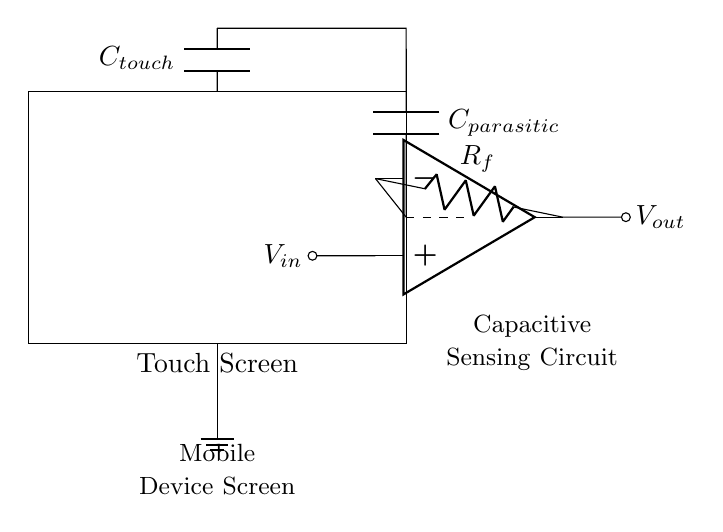What is the input voltage of the operational amplifier? The input voltage, represented as V_in in the circuit, is coming from a touch sensor, but the exact value is not labeled directly in the diagram. The analysis assumes a typical scenario where V_in may be a standard value like 3.3V or 5V.
Answer: V_in What type of capacitor is represented by C_touch? C_touch is a capacitive touch sensor which detects the change in capacitance caused by a user touching the screen. This type of capacitor is specifically designed for touch sensing applications.
Answer: Capacitive touch sensor What is the function of R_f in this circuit? R_f is a feedback resistor connected between the output and the inverting input of the operational amplifier. Its primary function is to set the gain of the amplifier circuit, influencing the sensitivity of the capacitive sensing.
Answer: Feedback resistor How does the parasitic capacitance affect the sensing capability? Parasitic capacitance, represented in the circuit as C_parasitic, can negatively influence the accuracy and reliability of touch detection by creating noise or false signals in conjunction with the intended capacitive touch.
Answer: Negatively influences detection What would happen if C_touch is removed from the circuit? If C_touch is removed, the circuit will not be able to detect touches on the mobile device screen, rendering the touch functionality inoperative. The operational amplifier would not have the necessary sensor input required for operation.
Answer: Inoperative touch functionality 